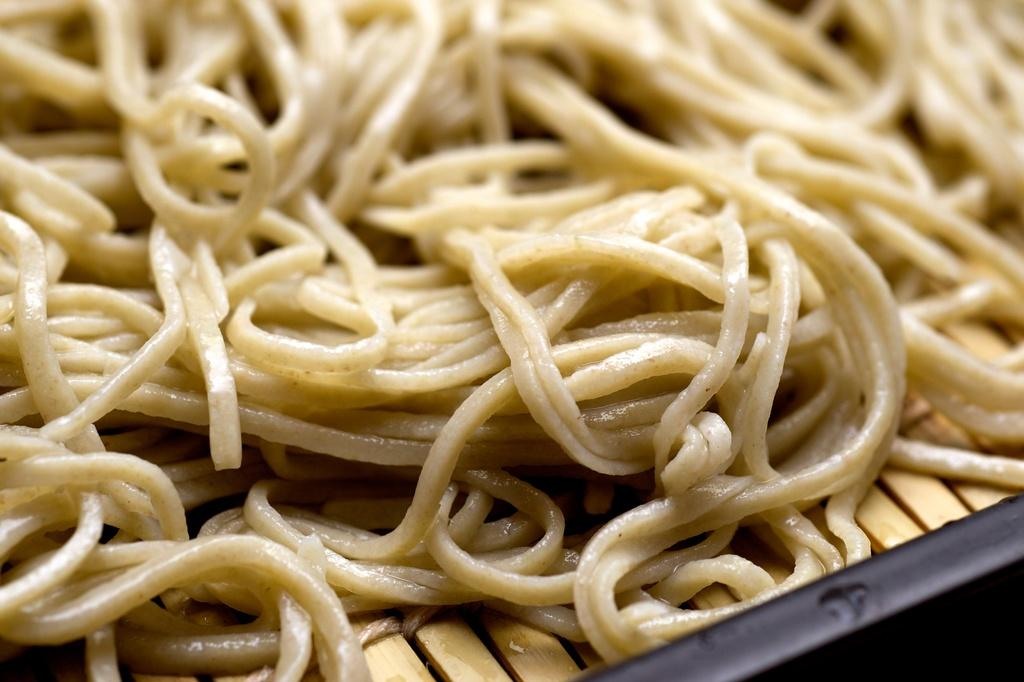What type of food is visible in the image? There are boiled noodles in the image. Where is the tray located in the image? The tray is in the right bottom of the image. What is the smell of the oranges in the image? There are no oranges present in the image, so it is not possible to determine their smell. 